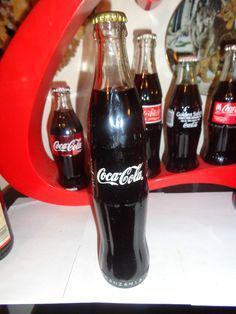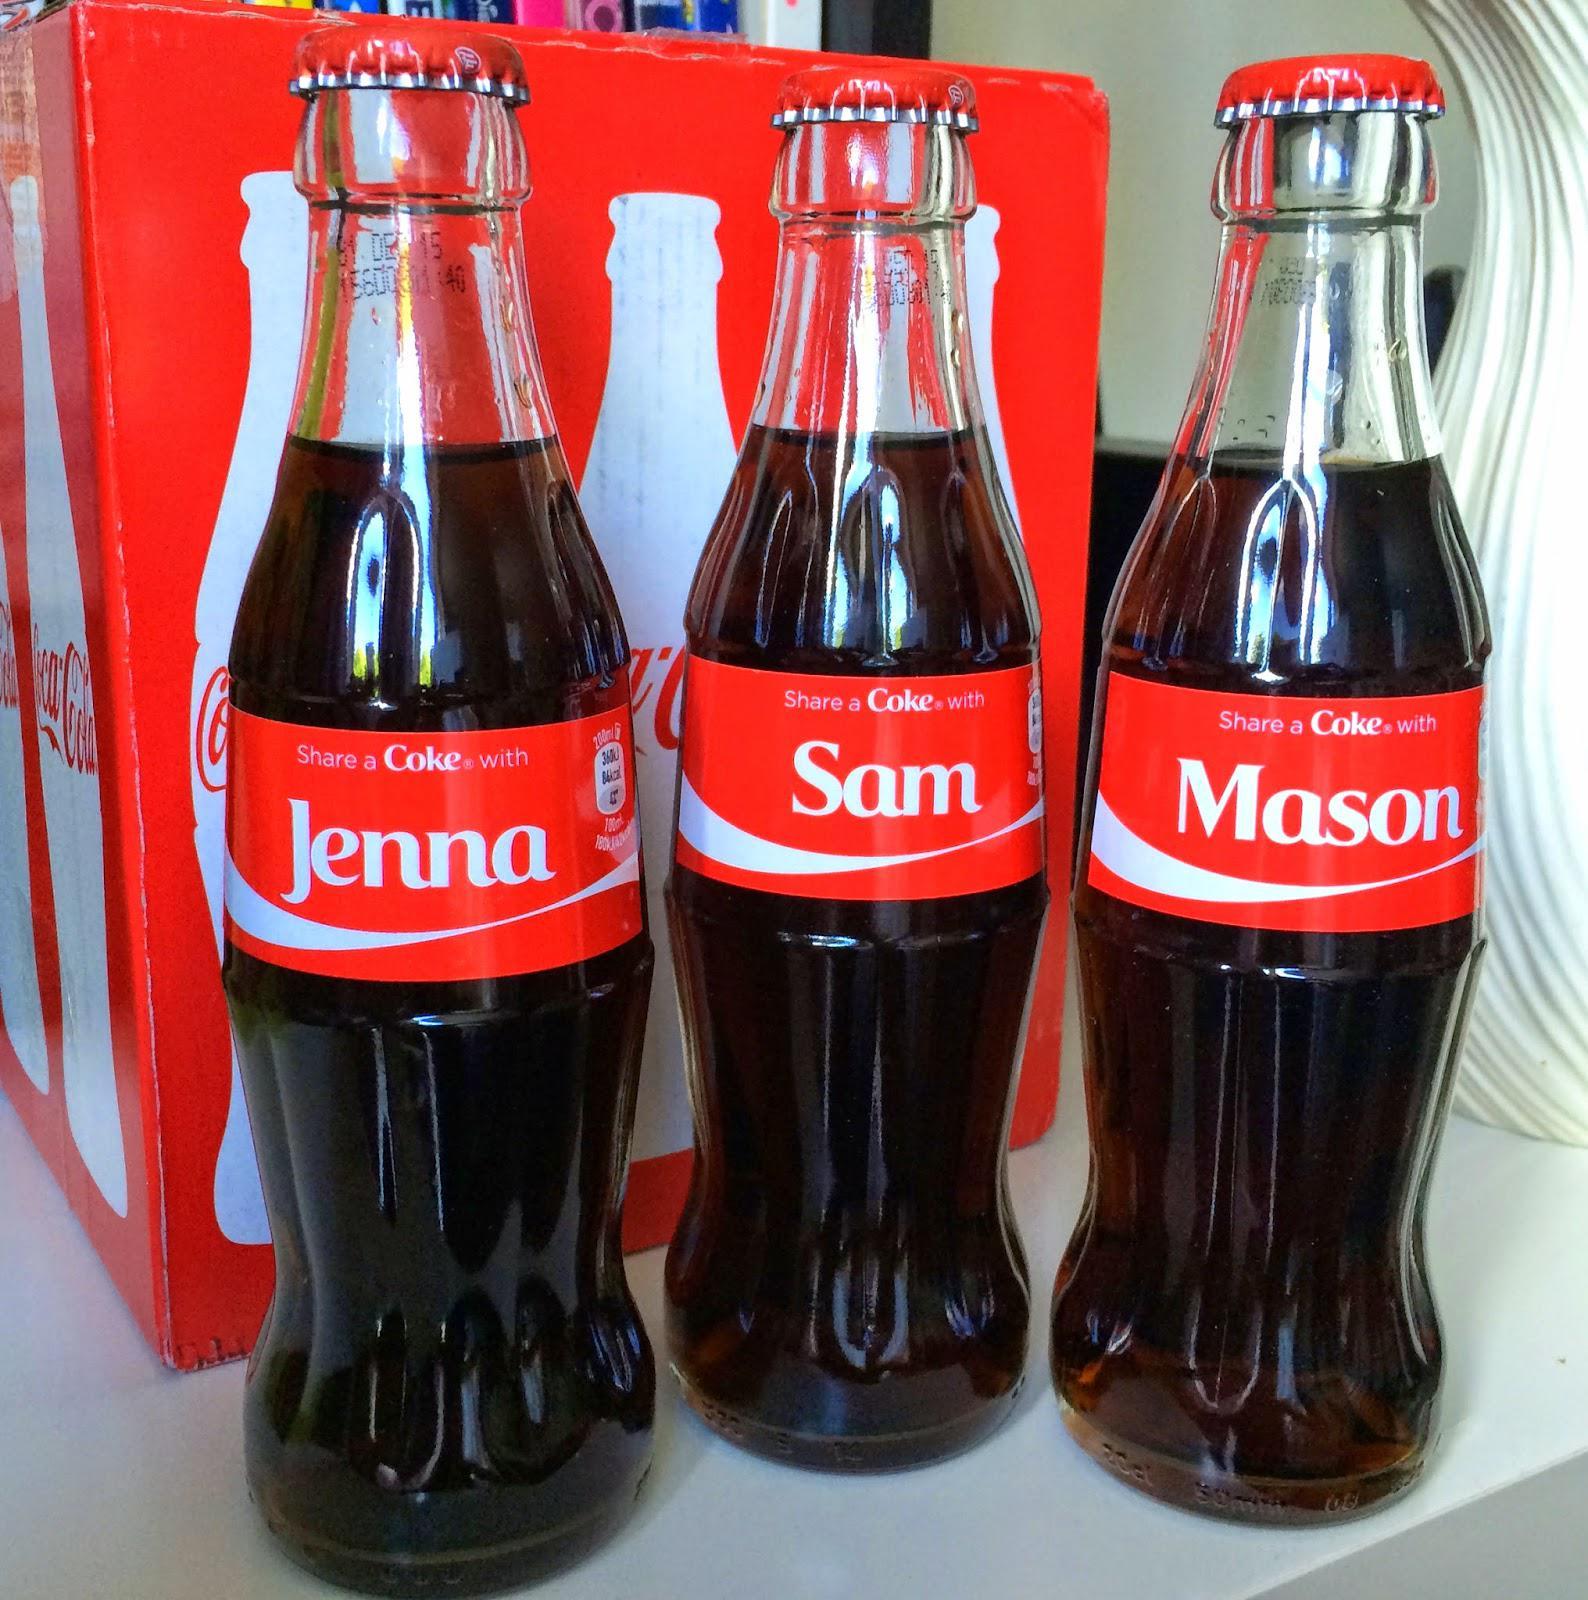The first image is the image on the left, the second image is the image on the right. Assess this claim about the two images: "The front most bottle in each of the images has a similarly colored label.". Correct or not? Answer yes or no. No. The first image is the image on the left, the second image is the image on the right. Considering the images on both sides, is "Two bottles are standing in front of all the others." valid? Answer yes or no. No. 